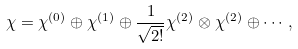<formula> <loc_0><loc_0><loc_500><loc_500>\chi = \chi ^ { ( 0 ) } \oplus \chi ^ { ( 1 ) } \oplus \frac { 1 } { \sqrt { 2 ! } } \chi ^ { ( 2 ) } \otimes \chi ^ { ( 2 ) } \oplus \cdots ,</formula> 